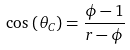Convert formula to latex. <formula><loc_0><loc_0><loc_500><loc_500>\cos \, \left ( \theta _ { C } \right ) = { \frac { \phi - 1 } { r - \phi } }</formula> 